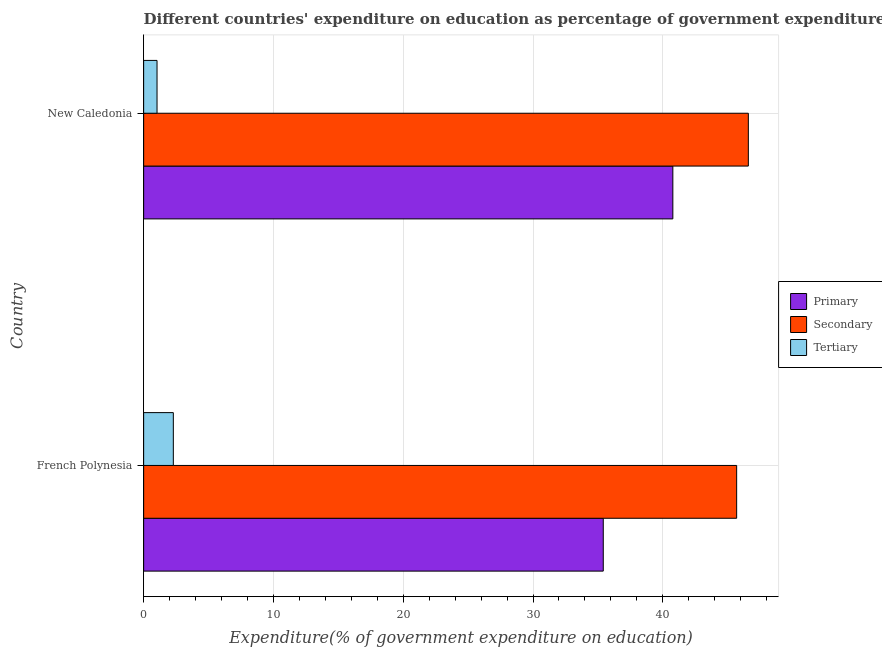How many different coloured bars are there?
Your answer should be compact. 3. Are the number of bars per tick equal to the number of legend labels?
Offer a terse response. Yes. How many bars are there on the 2nd tick from the top?
Offer a terse response. 3. What is the label of the 2nd group of bars from the top?
Your response must be concise. French Polynesia. In how many cases, is the number of bars for a given country not equal to the number of legend labels?
Offer a very short reply. 0. What is the expenditure on tertiary education in New Caledonia?
Your answer should be very brief. 1.03. Across all countries, what is the maximum expenditure on secondary education?
Your answer should be compact. 46.59. Across all countries, what is the minimum expenditure on tertiary education?
Keep it short and to the point. 1.03. In which country was the expenditure on tertiary education maximum?
Give a very brief answer. French Polynesia. In which country was the expenditure on primary education minimum?
Provide a short and direct response. French Polynesia. What is the total expenditure on secondary education in the graph?
Ensure brevity in your answer.  92.28. What is the difference between the expenditure on secondary education in French Polynesia and that in New Caledonia?
Ensure brevity in your answer.  -0.9. What is the difference between the expenditure on tertiary education in French Polynesia and the expenditure on primary education in New Caledonia?
Provide a short and direct response. -38.49. What is the average expenditure on tertiary education per country?
Provide a short and direct response. 1.66. What is the difference between the expenditure on secondary education and expenditure on tertiary education in French Polynesia?
Make the answer very short. 43.4. In how many countries, is the expenditure on secondary education greater than 18 %?
Give a very brief answer. 2. What is the ratio of the expenditure on primary education in French Polynesia to that in New Caledonia?
Your answer should be very brief. 0.87. Is the expenditure on secondary education in French Polynesia less than that in New Caledonia?
Your answer should be compact. Yes. Is the difference between the expenditure on tertiary education in French Polynesia and New Caledonia greater than the difference between the expenditure on primary education in French Polynesia and New Caledonia?
Your response must be concise. Yes. In how many countries, is the expenditure on secondary education greater than the average expenditure on secondary education taken over all countries?
Your answer should be very brief. 1. What does the 1st bar from the top in French Polynesia represents?
Your answer should be compact. Tertiary. What does the 1st bar from the bottom in New Caledonia represents?
Your answer should be very brief. Primary. How many bars are there?
Make the answer very short. 6. Does the graph contain any zero values?
Provide a succinct answer. No. Does the graph contain grids?
Your answer should be compact. Yes. Where does the legend appear in the graph?
Provide a succinct answer. Center right. What is the title of the graph?
Give a very brief answer. Different countries' expenditure on education as percentage of government expenditure. Does "Domestic economy" appear as one of the legend labels in the graph?
Provide a short and direct response. No. What is the label or title of the X-axis?
Make the answer very short. Expenditure(% of government expenditure on education). What is the Expenditure(% of government expenditure on education) of Primary in French Polynesia?
Give a very brief answer. 35.41. What is the Expenditure(% of government expenditure on education) in Secondary in French Polynesia?
Keep it short and to the point. 45.69. What is the Expenditure(% of government expenditure on education) in Tertiary in French Polynesia?
Offer a terse response. 2.29. What is the Expenditure(% of government expenditure on education) in Primary in New Caledonia?
Provide a short and direct response. 40.77. What is the Expenditure(% of government expenditure on education) of Secondary in New Caledonia?
Your response must be concise. 46.59. What is the Expenditure(% of government expenditure on education) of Tertiary in New Caledonia?
Your answer should be compact. 1.03. Across all countries, what is the maximum Expenditure(% of government expenditure on education) of Primary?
Provide a short and direct response. 40.77. Across all countries, what is the maximum Expenditure(% of government expenditure on education) of Secondary?
Make the answer very short. 46.59. Across all countries, what is the maximum Expenditure(% of government expenditure on education) in Tertiary?
Your answer should be very brief. 2.29. Across all countries, what is the minimum Expenditure(% of government expenditure on education) of Primary?
Your answer should be compact. 35.41. Across all countries, what is the minimum Expenditure(% of government expenditure on education) of Secondary?
Provide a succinct answer. 45.69. Across all countries, what is the minimum Expenditure(% of government expenditure on education) in Tertiary?
Keep it short and to the point. 1.03. What is the total Expenditure(% of government expenditure on education) in Primary in the graph?
Your answer should be very brief. 76.19. What is the total Expenditure(% of government expenditure on education) in Secondary in the graph?
Make the answer very short. 92.28. What is the total Expenditure(% of government expenditure on education) in Tertiary in the graph?
Provide a succinct answer. 3.32. What is the difference between the Expenditure(% of government expenditure on education) in Primary in French Polynesia and that in New Caledonia?
Offer a very short reply. -5.36. What is the difference between the Expenditure(% of government expenditure on education) of Secondary in French Polynesia and that in New Caledonia?
Keep it short and to the point. -0.9. What is the difference between the Expenditure(% of government expenditure on education) of Tertiary in French Polynesia and that in New Caledonia?
Offer a terse response. 1.26. What is the difference between the Expenditure(% of government expenditure on education) in Primary in French Polynesia and the Expenditure(% of government expenditure on education) in Secondary in New Caledonia?
Your answer should be compact. -11.18. What is the difference between the Expenditure(% of government expenditure on education) in Primary in French Polynesia and the Expenditure(% of government expenditure on education) in Tertiary in New Caledonia?
Give a very brief answer. 34.38. What is the difference between the Expenditure(% of government expenditure on education) of Secondary in French Polynesia and the Expenditure(% of government expenditure on education) of Tertiary in New Caledonia?
Ensure brevity in your answer.  44.66. What is the average Expenditure(% of government expenditure on education) in Primary per country?
Ensure brevity in your answer.  38.09. What is the average Expenditure(% of government expenditure on education) in Secondary per country?
Keep it short and to the point. 46.14. What is the average Expenditure(% of government expenditure on education) of Tertiary per country?
Provide a succinct answer. 1.66. What is the difference between the Expenditure(% of government expenditure on education) of Primary and Expenditure(% of government expenditure on education) of Secondary in French Polynesia?
Provide a succinct answer. -10.28. What is the difference between the Expenditure(% of government expenditure on education) in Primary and Expenditure(% of government expenditure on education) in Tertiary in French Polynesia?
Provide a succinct answer. 33.13. What is the difference between the Expenditure(% of government expenditure on education) of Secondary and Expenditure(% of government expenditure on education) of Tertiary in French Polynesia?
Offer a terse response. 43.4. What is the difference between the Expenditure(% of government expenditure on education) of Primary and Expenditure(% of government expenditure on education) of Secondary in New Caledonia?
Provide a succinct answer. -5.82. What is the difference between the Expenditure(% of government expenditure on education) of Primary and Expenditure(% of government expenditure on education) of Tertiary in New Caledonia?
Ensure brevity in your answer.  39.74. What is the difference between the Expenditure(% of government expenditure on education) in Secondary and Expenditure(% of government expenditure on education) in Tertiary in New Caledonia?
Give a very brief answer. 45.56. What is the ratio of the Expenditure(% of government expenditure on education) in Primary in French Polynesia to that in New Caledonia?
Keep it short and to the point. 0.87. What is the ratio of the Expenditure(% of government expenditure on education) in Secondary in French Polynesia to that in New Caledonia?
Provide a short and direct response. 0.98. What is the ratio of the Expenditure(% of government expenditure on education) of Tertiary in French Polynesia to that in New Caledonia?
Keep it short and to the point. 2.22. What is the difference between the highest and the second highest Expenditure(% of government expenditure on education) of Primary?
Ensure brevity in your answer.  5.36. What is the difference between the highest and the second highest Expenditure(% of government expenditure on education) in Secondary?
Make the answer very short. 0.9. What is the difference between the highest and the second highest Expenditure(% of government expenditure on education) of Tertiary?
Keep it short and to the point. 1.26. What is the difference between the highest and the lowest Expenditure(% of government expenditure on education) of Primary?
Make the answer very short. 5.36. What is the difference between the highest and the lowest Expenditure(% of government expenditure on education) of Secondary?
Your answer should be very brief. 0.9. What is the difference between the highest and the lowest Expenditure(% of government expenditure on education) in Tertiary?
Ensure brevity in your answer.  1.26. 